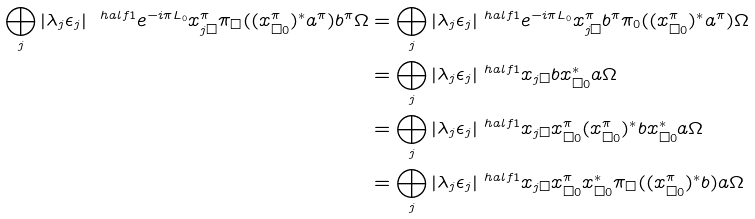Convert formula to latex. <formula><loc_0><loc_0><loc_500><loc_500>\bigoplus _ { j } | \lambda _ { j } \epsilon _ { j } | ^ { \ h a l f { 1 } } e ^ { - i \pi L _ { 0 } } x _ { j \Box } ^ { \pi } \pi _ { \Box } ( ( x _ { \Box 0 } ^ { \pi } ) ^ { * } a ^ { \pi } ) b ^ { \pi } \Omega & = \bigoplus _ { j } | \lambda _ { j } \epsilon _ { j } | ^ { \ h a l f { 1 } } e ^ { - i \pi L _ { 0 } } x _ { j \Box } ^ { \pi } b ^ { \pi } \pi _ { 0 } ( ( x _ { \Box 0 } ^ { \pi } ) ^ { * } a ^ { \pi } ) \Omega \\ & = \bigoplus _ { j } | \lambda _ { j } \epsilon _ { j } | ^ { \ h a l f { 1 } } x _ { j \Box } b x _ { \Box 0 } ^ { * } a \Omega \\ & = \bigoplus _ { j } | \lambda _ { j } \epsilon _ { j } | ^ { \ h a l f { 1 } } x _ { j \Box } x _ { \Box 0 } ^ { \pi } ( x _ { \Box 0 } ^ { \pi } ) ^ { * } b x _ { \Box 0 } ^ { * } a \Omega \\ & = \bigoplus _ { j } | \lambda _ { j } \epsilon _ { j } | ^ { \ h a l f { 1 } } x _ { j \Box } x _ { \Box 0 } ^ { \pi } x _ { \Box 0 } ^ { * } \pi _ { \Box } ( ( x _ { \Box 0 } ^ { \pi } ) ^ { * } b ) a \Omega</formula> 